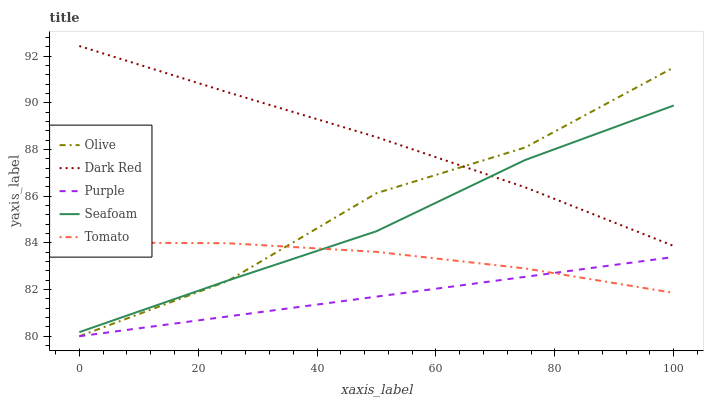Does Purple have the minimum area under the curve?
Answer yes or no. Yes. Does Dark Red have the maximum area under the curve?
Answer yes or no. Yes. Does Tomato have the minimum area under the curve?
Answer yes or no. No. Does Tomato have the maximum area under the curve?
Answer yes or no. No. Is Purple the smoothest?
Answer yes or no. Yes. Is Olive the roughest?
Answer yes or no. Yes. Is Dark Red the smoothest?
Answer yes or no. No. Is Dark Red the roughest?
Answer yes or no. No. Does Olive have the lowest value?
Answer yes or no. Yes. Does Tomato have the lowest value?
Answer yes or no. No. Does Dark Red have the highest value?
Answer yes or no. Yes. Does Tomato have the highest value?
Answer yes or no. No. Is Purple less than Seafoam?
Answer yes or no. Yes. Is Dark Red greater than Purple?
Answer yes or no. Yes. Does Dark Red intersect Olive?
Answer yes or no. Yes. Is Dark Red less than Olive?
Answer yes or no. No. Is Dark Red greater than Olive?
Answer yes or no. No. Does Purple intersect Seafoam?
Answer yes or no. No. 